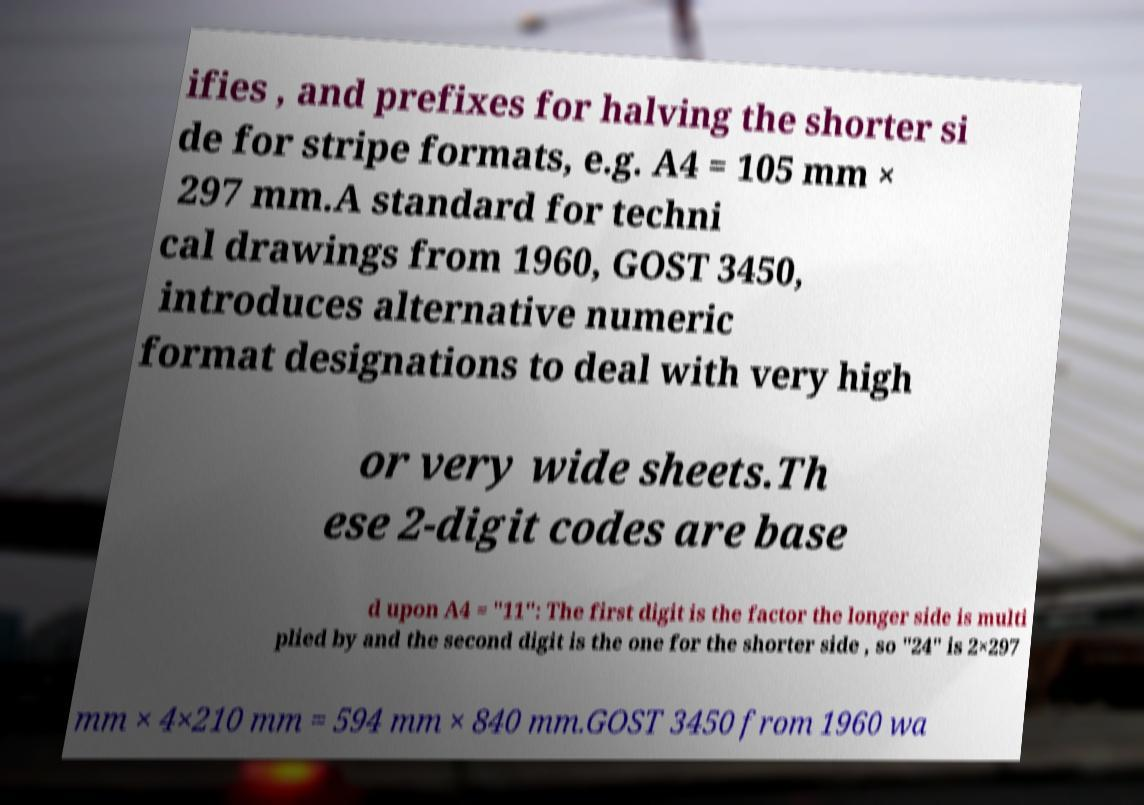For documentation purposes, I need the text within this image transcribed. Could you provide that? ifies , and prefixes for halving the shorter si de for stripe formats, e.g. A4 = 105 mm × 297 mm.A standard for techni cal drawings from 1960, GOST 3450, introduces alternative numeric format designations to deal with very high or very wide sheets.Th ese 2-digit codes are base d upon A4 = "11": The first digit is the factor the longer side is multi plied by and the second digit is the one for the shorter side , so "24" is 2×297 mm × 4×210 mm = 594 mm × 840 mm.GOST 3450 from 1960 wa 